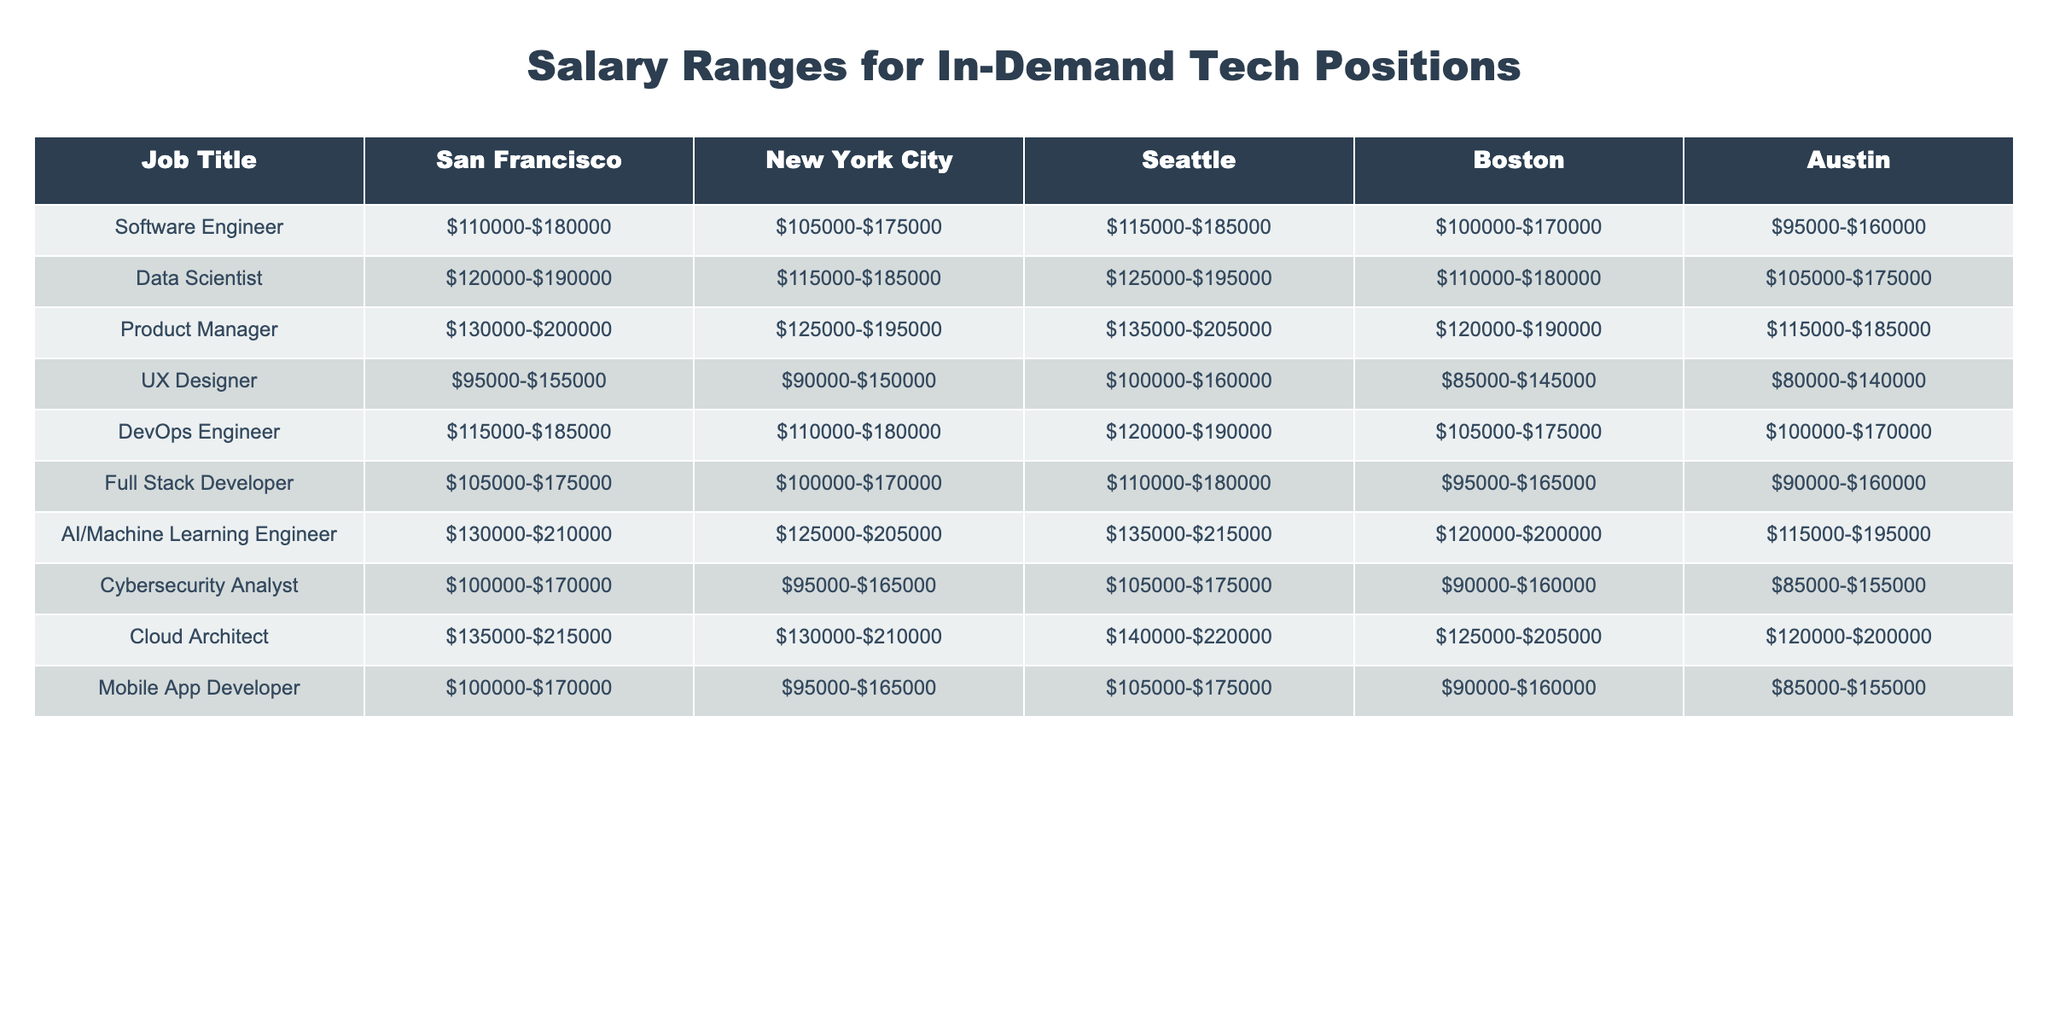What is the salary range for a Software Engineer in New York City? The table indicates the salary range for a Software Engineer in New York City is listed as $105,000-$175,000.
Answer: $105,000-$175,000 Which city offers the highest salary range for a Data Scientist? In the table, the salary range for a Data Scientist in San Francisco is $120,000-$190,000, which is higher than the ranges in other cities.
Answer: San Francisco What is the difference in salary range for a Mobile App Developer between Boston and Austin? The salary range for a Mobile App Developer in Boston is $90,000-$160,000, and in Austin, it’s $85,000-$155,000. The difference in the lower ends is $90,000 - $85,000 = $5,000, and for the upper ends, it’s $160,000 - $155,000 = $5,000.
Answer: $5,000 Which position has the lowest upper salary range in Seattle? The upper salary range for a UX Designer in Seattle is $160,000, which is the lowest compared to the other positions listed for that city.
Answer: UX Designer What is the average salary range for a Full Stack Developer across all listed cities? To find the average, we first sum the lower ends: $105,000 + $100,000 + $110,000 + $95,000 + $90,000 = $500,000. The upper ends are $175,000 + $170,000 + $180,000 + $165,000 + $160,000 = $850,000. Dividing each by 5 for the five cities gives us $100,000 for the lower average and $170,000 for the upper average, resulting in an average salary range of $100,000-$170,000.
Answer: $100,000-$170,000 Which position in Boston has the highest salary range? The table shows that the Product Manager position in Boston has a salary range of $120,000-$190,000, which is higher than the ranges for other positions in Boston.
Answer: Product Manager Is the salary range for Cybersecurity Analyst in New York City higher than in Austin? The salary range for Cybersecurity Analyst in New York City is $95,000-$165,000, while in Austin, it's $85,000-$155,000. Since both lower and upper ends are higher in New York City, the answer is yes.
Answer: Yes What is the median salary range for AI/Machine Learning Engineer among the five cities? The salary ranges for AI/Machine Learning Engineers are as follows: San Francisco $130,000-$210,000, New York City $125,000-$205,000, Seattle $135,000-$215,000, Boston $120,000-$200,000, and Austin $115,000-$195,000. The sorted ranges show the median would be between the second and the third values when combined, giving us a median of approximately $125,000-$205,000.
Answer: $125,000-$205,000 How does the salary range for a Cloud Architect in Seattle compare to that in San Francisco? The salary range for a Cloud Architect in Seattle is $140,000-$220,000, while in San Francisco it is $135,000-$215,000. Therefore, both ranges are examined: Seattle's range is higher for both lower and upper limits by $5,000 for the lower end and $5,000 for the upper end.
Answer: Seattle's range is higher Which job title has the widest salary range in Austin? By inspecting the table, the job title with the widest salary range in Austin is the Cloud Architect, with a range of $120,000-$200,000, indicating a $80,000 difference over that span.
Answer: Cloud Architect 